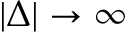Convert formula to latex. <formula><loc_0><loc_0><loc_500><loc_500>| \Delta | \rightarrow \infty</formula> 